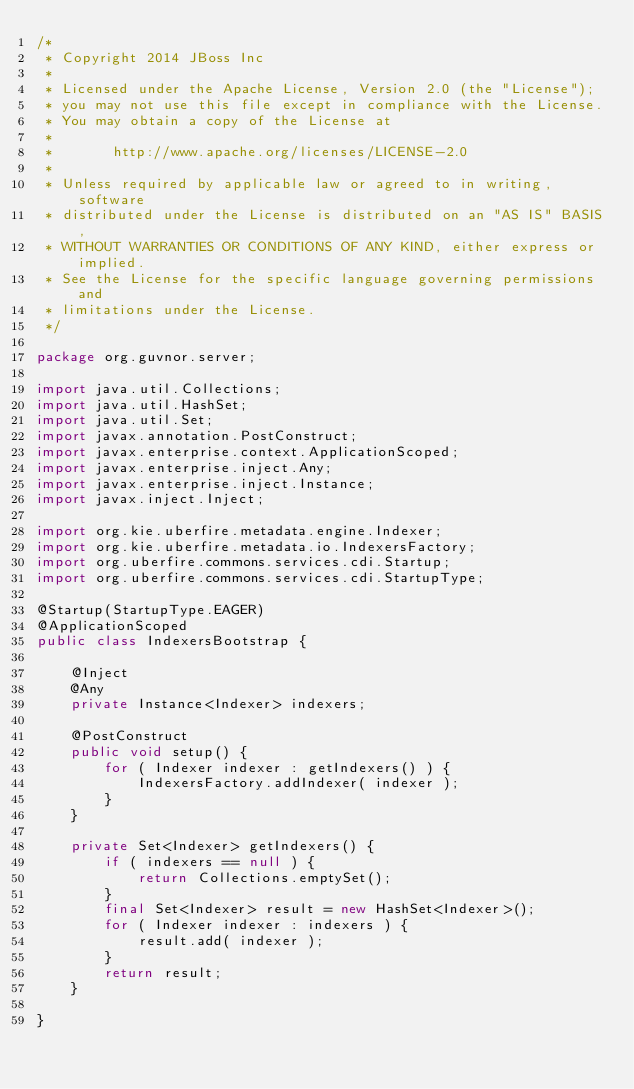Convert code to text. <code><loc_0><loc_0><loc_500><loc_500><_Java_>/*
 * Copyright 2014 JBoss Inc
 *
 * Licensed under the Apache License, Version 2.0 (the "License");
 * you may not use this file except in compliance with the License.
 * You may obtain a copy of the License at
 *
 *       http://www.apache.org/licenses/LICENSE-2.0
 *
 * Unless required by applicable law or agreed to in writing, software
 * distributed under the License is distributed on an "AS IS" BASIS,
 * WITHOUT WARRANTIES OR CONDITIONS OF ANY KIND, either express or implied.
 * See the License for the specific language governing permissions and
 * limitations under the License.
 */

package org.guvnor.server;

import java.util.Collections;
import java.util.HashSet;
import java.util.Set;
import javax.annotation.PostConstruct;
import javax.enterprise.context.ApplicationScoped;
import javax.enterprise.inject.Any;
import javax.enterprise.inject.Instance;
import javax.inject.Inject;

import org.kie.uberfire.metadata.engine.Indexer;
import org.kie.uberfire.metadata.io.IndexersFactory;
import org.uberfire.commons.services.cdi.Startup;
import org.uberfire.commons.services.cdi.StartupType;

@Startup(StartupType.EAGER)
@ApplicationScoped
public class IndexersBootstrap {

    @Inject
    @Any
    private Instance<Indexer> indexers;

    @PostConstruct
    public void setup() {
        for ( Indexer indexer : getIndexers() ) {
            IndexersFactory.addIndexer( indexer );
        }
    }

    private Set<Indexer> getIndexers() {
        if ( indexers == null ) {
            return Collections.emptySet();
        }
        final Set<Indexer> result = new HashSet<Indexer>();
        for ( Indexer indexer : indexers ) {
            result.add( indexer );
        }
        return result;
    }

}
</code> 